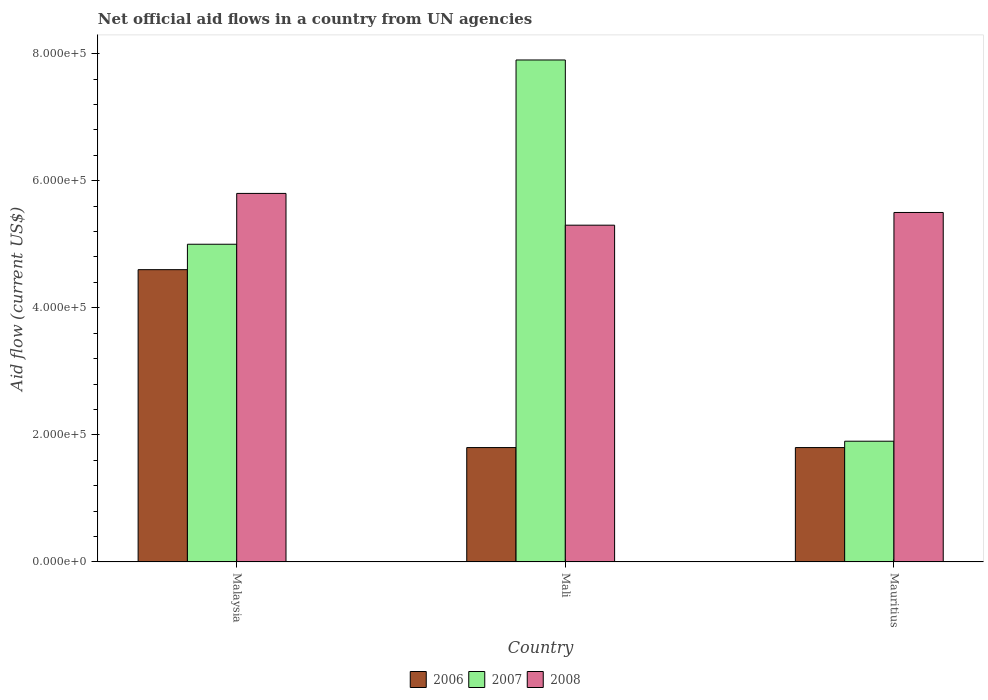How many groups of bars are there?
Your answer should be compact. 3. Are the number of bars per tick equal to the number of legend labels?
Your answer should be compact. Yes. How many bars are there on the 2nd tick from the right?
Offer a terse response. 3. What is the label of the 2nd group of bars from the left?
Offer a terse response. Mali. In how many cases, is the number of bars for a given country not equal to the number of legend labels?
Your response must be concise. 0. What is the net official aid flow in 2006 in Mali?
Ensure brevity in your answer.  1.80e+05. Across all countries, what is the maximum net official aid flow in 2008?
Your answer should be very brief. 5.80e+05. In which country was the net official aid flow in 2006 maximum?
Keep it short and to the point. Malaysia. In which country was the net official aid flow in 2008 minimum?
Your answer should be very brief. Mali. What is the total net official aid flow in 2008 in the graph?
Provide a short and direct response. 1.66e+06. What is the average net official aid flow in 2008 per country?
Give a very brief answer. 5.53e+05. In how many countries, is the net official aid flow in 2006 greater than 520000 US$?
Keep it short and to the point. 0. What is the ratio of the net official aid flow in 2008 in Malaysia to that in Mali?
Make the answer very short. 1.09. Is the net official aid flow in 2008 in Malaysia less than that in Mauritius?
Offer a terse response. No. Is the difference between the net official aid flow in 2008 in Malaysia and Mali greater than the difference between the net official aid flow in 2007 in Malaysia and Mali?
Ensure brevity in your answer.  Yes. What is the difference between the highest and the lowest net official aid flow in 2007?
Your answer should be compact. 6.00e+05. What does the 2nd bar from the left in Mauritius represents?
Offer a very short reply. 2007. Are all the bars in the graph horizontal?
Ensure brevity in your answer.  No. How many countries are there in the graph?
Provide a short and direct response. 3. What is the difference between two consecutive major ticks on the Y-axis?
Your answer should be very brief. 2.00e+05. Does the graph contain any zero values?
Your answer should be very brief. No. Does the graph contain grids?
Keep it short and to the point. No. What is the title of the graph?
Make the answer very short. Net official aid flows in a country from UN agencies. What is the label or title of the X-axis?
Keep it short and to the point. Country. What is the Aid flow (current US$) of 2007 in Malaysia?
Offer a terse response. 5.00e+05. What is the Aid flow (current US$) of 2008 in Malaysia?
Your answer should be compact. 5.80e+05. What is the Aid flow (current US$) of 2006 in Mali?
Offer a very short reply. 1.80e+05. What is the Aid flow (current US$) of 2007 in Mali?
Your answer should be very brief. 7.90e+05. What is the Aid flow (current US$) in 2008 in Mali?
Your answer should be compact. 5.30e+05. What is the Aid flow (current US$) of 2007 in Mauritius?
Your answer should be compact. 1.90e+05. Across all countries, what is the maximum Aid flow (current US$) in 2007?
Ensure brevity in your answer.  7.90e+05. Across all countries, what is the maximum Aid flow (current US$) in 2008?
Your answer should be compact. 5.80e+05. Across all countries, what is the minimum Aid flow (current US$) in 2006?
Your answer should be very brief. 1.80e+05. Across all countries, what is the minimum Aid flow (current US$) of 2007?
Ensure brevity in your answer.  1.90e+05. Across all countries, what is the minimum Aid flow (current US$) of 2008?
Your answer should be compact. 5.30e+05. What is the total Aid flow (current US$) of 2006 in the graph?
Keep it short and to the point. 8.20e+05. What is the total Aid flow (current US$) of 2007 in the graph?
Offer a very short reply. 1.48e+06. What is the total Aid flow (current US$) of 2008 in the graph?
Offer a terse response. 1.66e+06. What is the difference between the Aid flow (current US$) in 2008 in Malaysia and that in Mali?
Offer a very short reply. 5.00e+04. What is the difference between the Aid flow (current US$) in 2006 in Malaysia and that in Mauritius?
Provide a succinct answer. 2.80e+05. What is the difference between the Aid flow (current US$) of 2007 in Malaysia and that in Mauritius?
Offer a very short reply. 3.10e+05. What is the difference between the Aid flow (current US$) of 2006 in Malaysia and the Aid flow (current US$) of 2007 in Mali?
Ensure brevity in your answer.  -3.30e+05. What is the difference between the Aid flow (current US$) of 2006 in Malaysia and the Aid flow (current US$) of 2008 in Mali?
Your answer should be compact. -7.00e+04. What is the difference between the Aid flow (current US$) of 2007 in Malaysia and the Aid flow (current US$) of 2008 in Mali?
Give a very brief answer. -3.00e+04. What is the difference between the Aid flow (current US$) of 2006 in Malaysia and the Aid flow (current US$) of 2007 in Mauritius?
Your answer should be compact. 2.70e+05. What is the difference between the Aid flow (current US$) of 2007 in Malaysia and the Aid flow (current US$) of 2008 in Mauritius?
Keep it short and to the point. -5.00e+04. What is the difference between the Aid flow (current US$) in 2006 in Mali and the Aid flow (current US$) in 2007 in Mauritius?
Provide a short and direct response. -10000. What is the difference between the Aid flow (current US$) of 2006 in Mali and the Aid flow (current US$) of 2008 in Mauritius?
Keep it short and to the point. -3.70e+05. What is the difference between the Aid flow (current US$) in 2007 in Mali and the Aid flow (current US$) in 2008 in Mauritius?
Offer a terse response. 2.40e+05. What is the average Aid flow (current US$) of 2006 per country?
Offer a terse response. 2.73e+05. What is the average Aid flow (current US$) of 2007 per country?
Offer a terse response. 4.93e+05. What is the average Aid flow (current US$) of 2008 per country?
Your response must be concise. 5.53e+05. What is the difference between the Aid flow (current US$) in 2006 and Aid flow (current US$) in 2008 in Malaysia?
Give a very brief answer. -1.20e+05. What is the difference between the Aid flow (current US$) of 2006 and Aid flow (current US$) of 2007 in Mali?
Your answer should be very brief. -6.10e+05. What is the difference between the Aid flow (current US$) in 2006 and Aid flow (current US$) in 2008 in Mali?
Your response must be concise. -3.50e+05. What is the difference between the Aid flow (current US$) of 2006 and Aid flow (current US$) of 2008 in Mauritius?
Ensure brevity in your answer.  -3.70e+05. What is the difference between the Aid flow (current US$) of 2007 and Aid flow (current US$) of 2008 in Mauritius?
Your response must be concise. -3.60e+05. What is the ratio of the Aid flow (current US$) in 2006 in Malaysia to that in Mali?
Your response must be concise. 2.56. What is the ratio of the Aid flow (current US$) in 2007 in Malaysia to that in Mali?
Provide a short and direct response. 0.63. What is the ratio of the Aid flow (current US$) of 2008 in Malaysia to that in Mali?
Keep it short and to the point. 1.09. What is the ratio of the Aid flow (current US$) of 2006 in Malaysia to that in Mauritius?
Your answer should be compact. 2.56. What is the ratio of the Aid flow (current US$) in 2007 in Malaysia to that in Mauritius?
Your response must be concise. 2.63. What is the ratio of the Aid flow (current US$) of 2008 in Malaysia to that in Mauritius?
Keep it short and to the point. 1.05. What is the ratio of the Aid flow (current US$) in 2006 in Mali to that in Mauritius?
Ensure brevity in your answer.  1. What is the ratio of the Aid flow (current US$) in 2007 in Mali to that in Mauritius?
Make the answer very short. 4.16. What is the ratio of the Aid flow (current US$) in 2008 in Mali to that in Mauritius?
Offer a terse response. 0.96. What is the difference between the highest and the second highest Aid flow (current US$) in 2006?
Offer a very short reply. 2.80e+05. What is the difference between the highest and the lowest Aid flow (current US$) of 2006?
Offer a very short reply. 2.80e+05. What is the difference between the highest and the lowest Aid flow (current US$) in 2007?
Provide a short and direct response. 6.00e+05. What is the difference between the highest and the lowest Aid flow (current US$) in 2008?
Provide a succinct answer. 5.00e+04. 